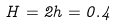Convert formula to latex. <formula><loc_0><loc_0><loc_500><loc_500>H = 2 h = 0 . 4</formula> 